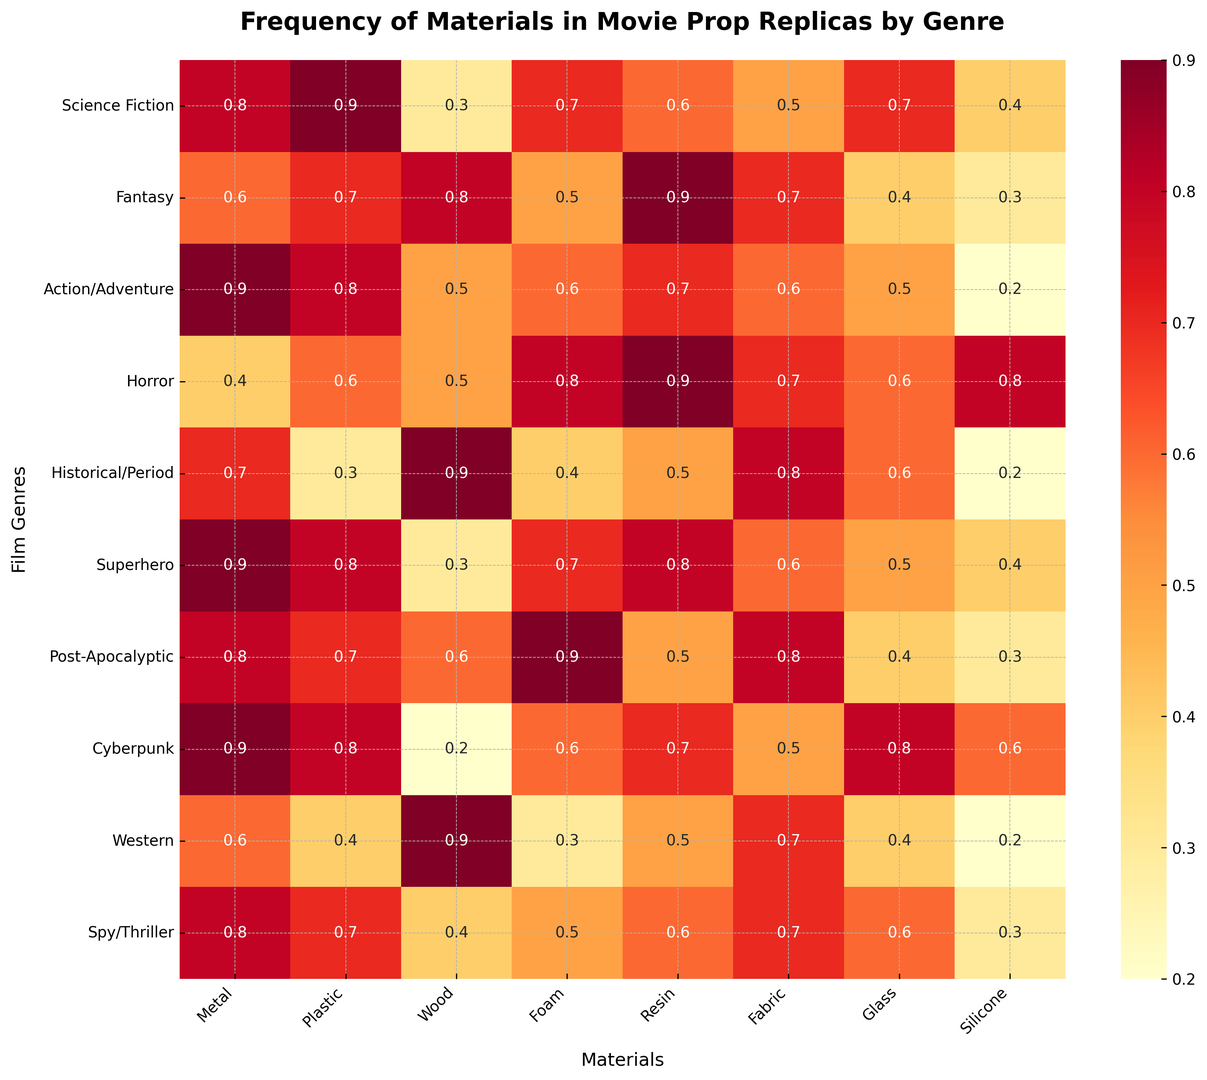Which genre uses the highest frequency of Metal? By examining the heatmap for the Metal column, we see that the highest frequency for Metal is 0.9. This value is found for the genres Action/Adventure, Cyberpunk, and Superhero.
Answer: Action/Adventure, Cyberpunk, Superhero Which material is used the most in Fantasy genre? In the Fantasy row, we look for the highest value among all materials. The highest value is 0.9, found in the Resin column.
Answer: Resin Which genre has the highest usage of Wood? By comparing the Wood column, we see that the highest value is 0.9. This is found in the genres Fantasy, Historical/Period, and Western.
Answer: Fantasy, Historical/Period, Western What is the combined frequency of Resin and Fabric in Post-Apocalyptic genre? In the Post-Apocalyptic row, we identify the values for Resin (0.5) and Fabric (0.8). Summing these values results in a combined frequency of 1.3.
Answer: 1.3 Which genre has the most balanced usage of different materials (i.e., the least variance in frequencies)? To find the genre with the most balanced usage, we need to consider the variance of the values. Visual inspection shows that the values for Spy/Thriller are quite uniform, without extreme highs or lows.
Answer: Spy/Thriller Compare the usage of Foam in Horror and Action/Adventure genres. Which uses more and by how much? The Horror genre has a Foam usage frequency of 0.8, while Action/Adventure has 0.6. The difference is 0.8 - 0.6 = 0.2.
Answer: Horror by 0.2 Which materials are used equally in Science Fiction and Superhero genres? By comparing the rows for Science Fiction and Superhero, we can see that Plastic (0.8) and Metal (0.9) are used equally in both genres.
Answer: Plastic, Metal What is the total frequency of all materials in the Cyberpunk genre? Summing all the values in the Cyberpunk row: 0.9 (Metal) + 0.8 (Plastic) + 0.2 (Wood) + 0.6 (Foam) + 0.7 (Resin) + 0.5 (Fabric) + 0.8 (Glass) + 0.6 (Silicone) = 5.1.
Answer: 5.1 In which genre is Glass less commonly used, Horror or Science Fiction? The usage of Glass in Horror is 0.6, and in Science Fiction, it's 0.7. Since 0.6 < 0.7, Glass is less commonly used in the Horror genre.
Answer: Horror 